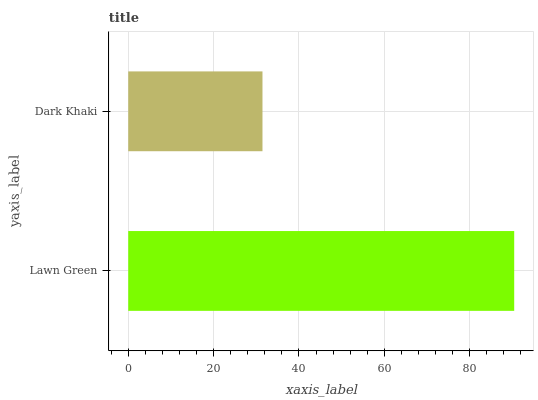Is Dark Khaki the minimum?
Answer yes or no. Yes. Is Lawn Green the maximum?
Answer yes or no. Yes. Is Dark Khaki the maximum?
Answer yes or no. No. Is Lawn Green greater than Dark Khaki?
Answer yes or no. Yes. Is Dark Khaki less than Lawn Green?
Answer yes or no. Yes. Is Dark Khaki greater than Lawn Green?
Answer yes or no. No. Is Lawn Green less than Dark Khaki?
Answer yes or no. No. Is Lawn Green the high median?
Answer yes or no. Yes. Is Dark Khaki the low median?
Answer yes or no. Yes. Is Dark Khaki the high median?
Answer yes or no. No. Is Lawn Green the low median?
Answer yes or no. No. 